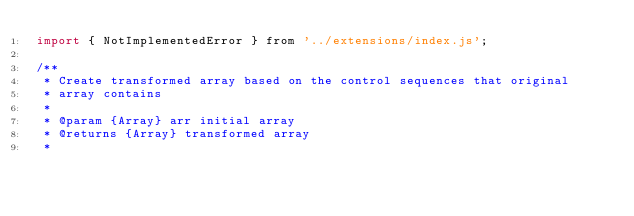Convert code to text. <code><loc_0><loc_0><loc_500><loc_500><_JavaScript_>import { NotImplementedError } from '../extensions/index.js';

/**
 * Create transformed array based on the control sequences that original
 * array contains
 * 
 * @param {Array} arr initial array
 * @returns {Array} transformed array
 * </code> 